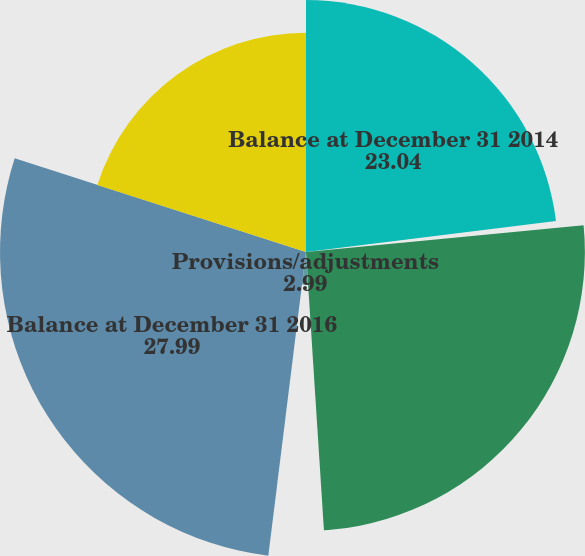Convert chart. <chart><loc_0><loc_0><loc_500><loc_500><pie_chart><fcel>Balance at December 31 2014<fcel>Cash reductions<fcel>Balance at December 31 2015<fcel>Provisions/adjustments<fcel>Balance at December 31 2016<fcel>Balance at December 31 2017<nl><fcel>23.04%<fcel>0.43%<fcel>25.51%<fcel>2.99%<fcel>27.99%<fcel>20.05%<nl></chart> 